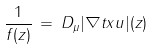Convert formula to latex. <formula><loc_0><loc_0><loc_500><loc_500>\frac { 1 } { f ( z ) } \, = \, D _ { \mu } | \nabla t x u | ( z )</formula> 